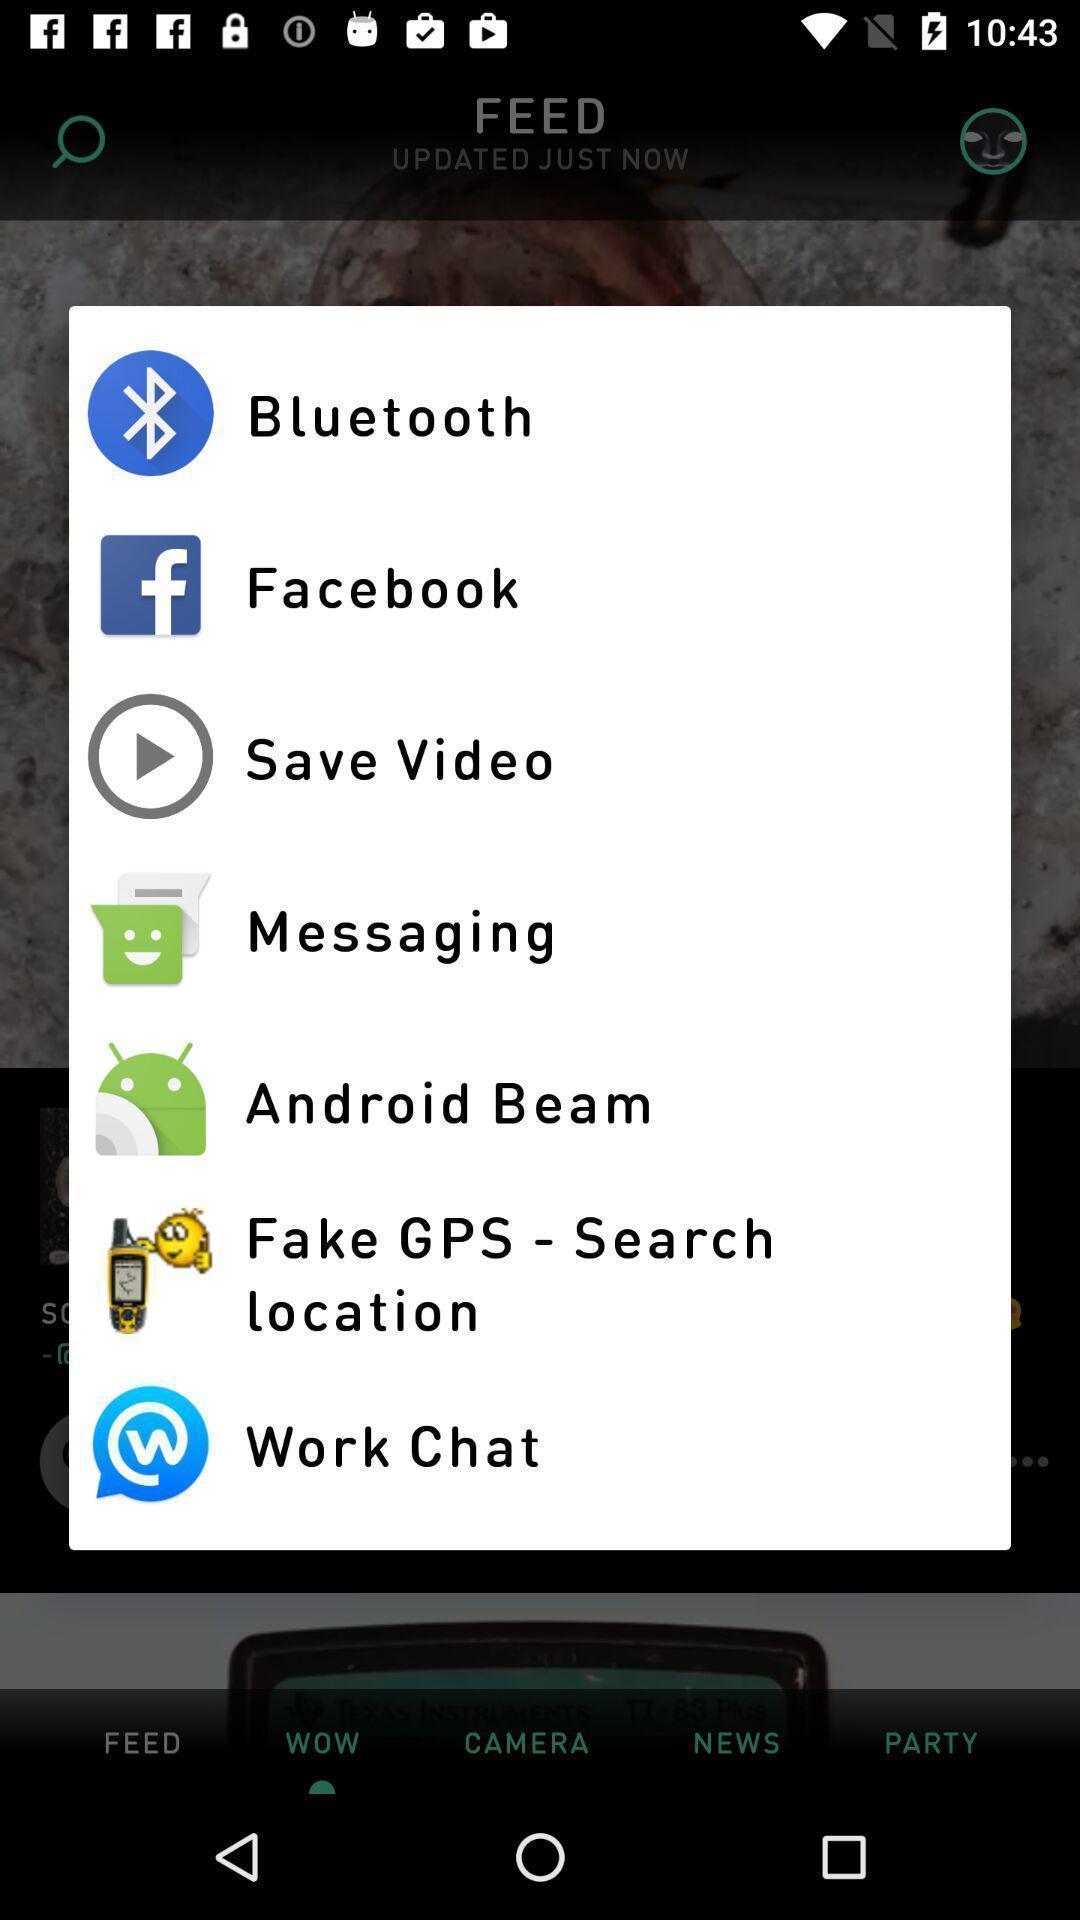Describe the content in this image. Pop-up showing the multiple social app options. 